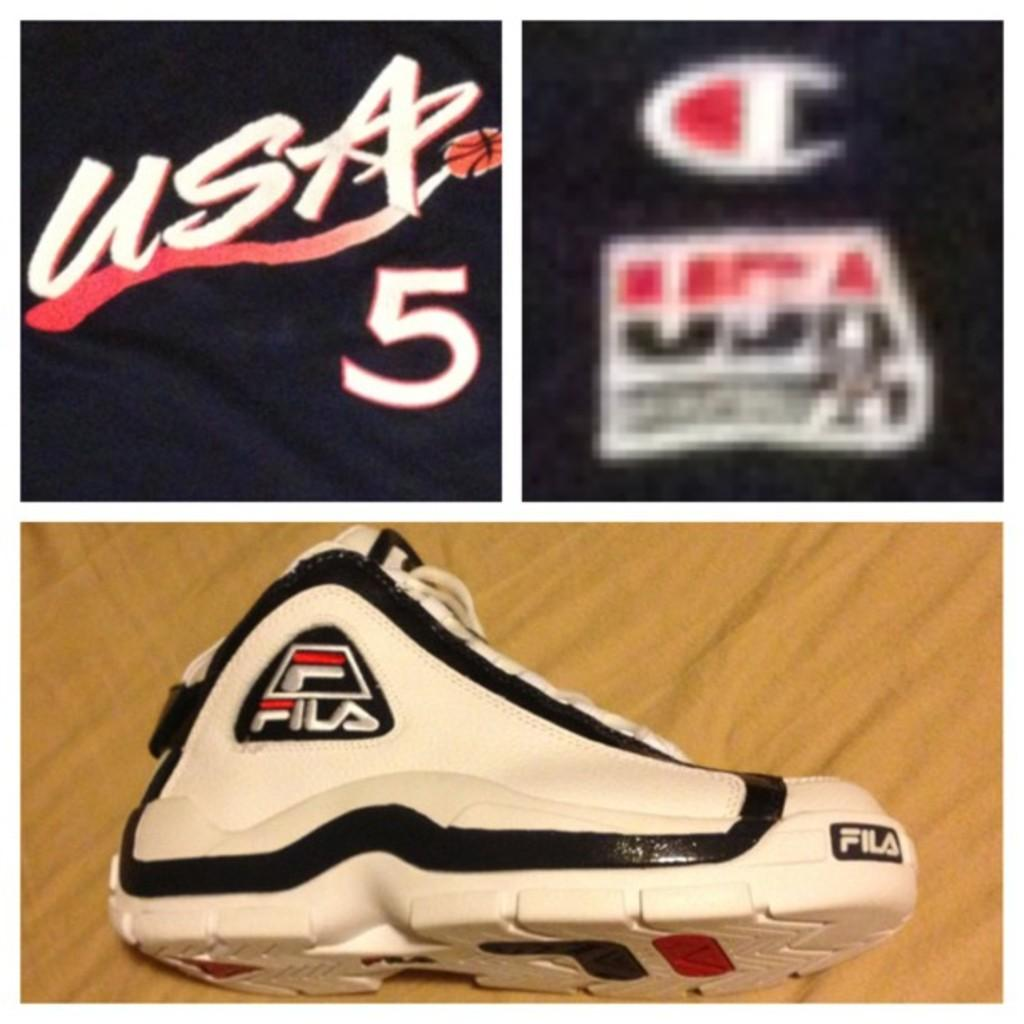<image>
Render a clear and concise summary of the photo. A pair of Fila shoes can be seen below USA and the number 5. 